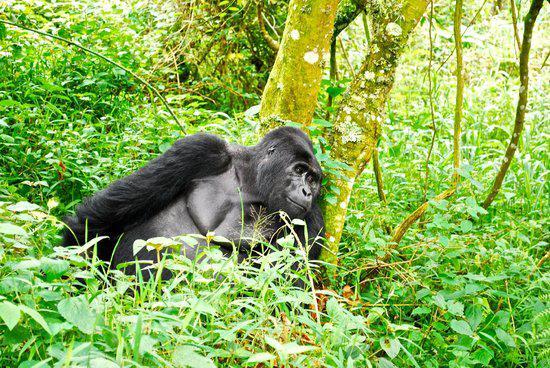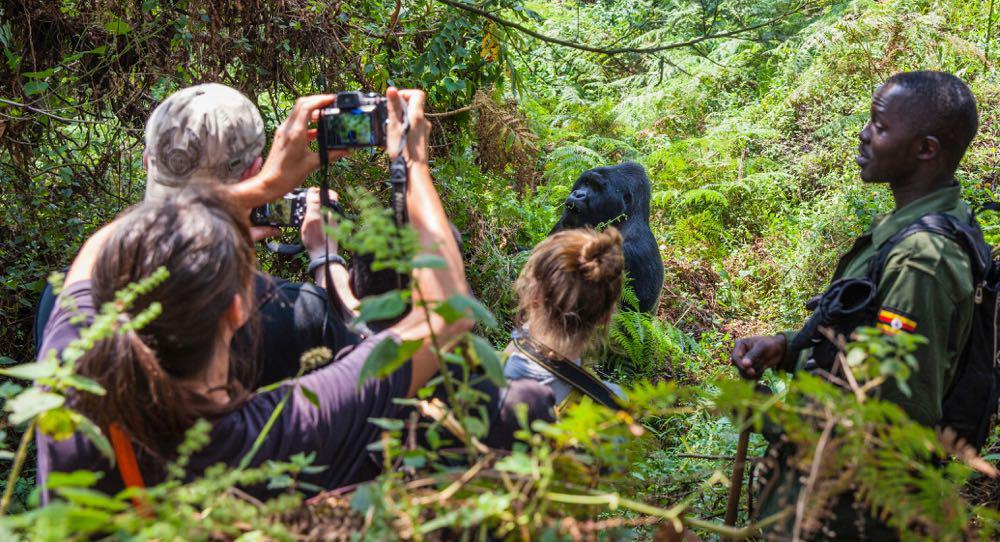The first image is the image on the left, the second image is the image on the right. For the images displayed, is the sentence "In the right image, multiple people are near an adult gorilla, and at least one person is holding up a camera." factually correct? Answer yes or no. Yes. The first image is the image on the left, the second image is the image on the right. Analyze the images presented: Is the assertion "There are humans taking pictures of apes in one of the images." valid? Answer yes or no. Yes. 